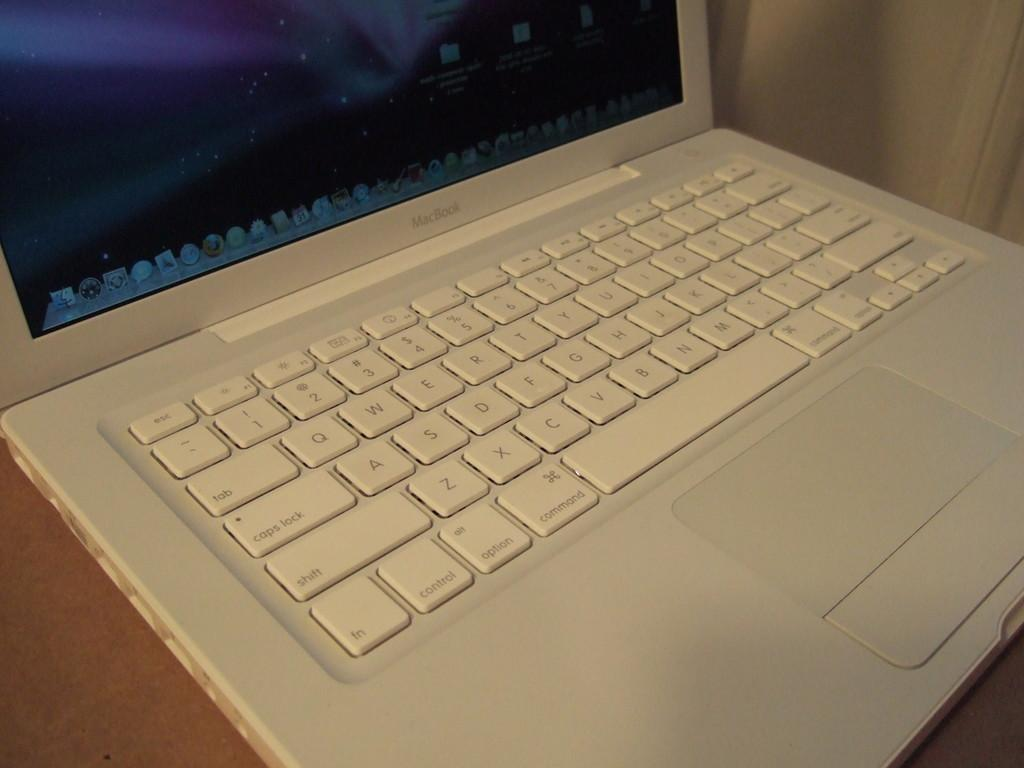<image>
Relay a brief, clear account of the picture shown. A white MacBook is open and there is a colorful sky on the monitor. 